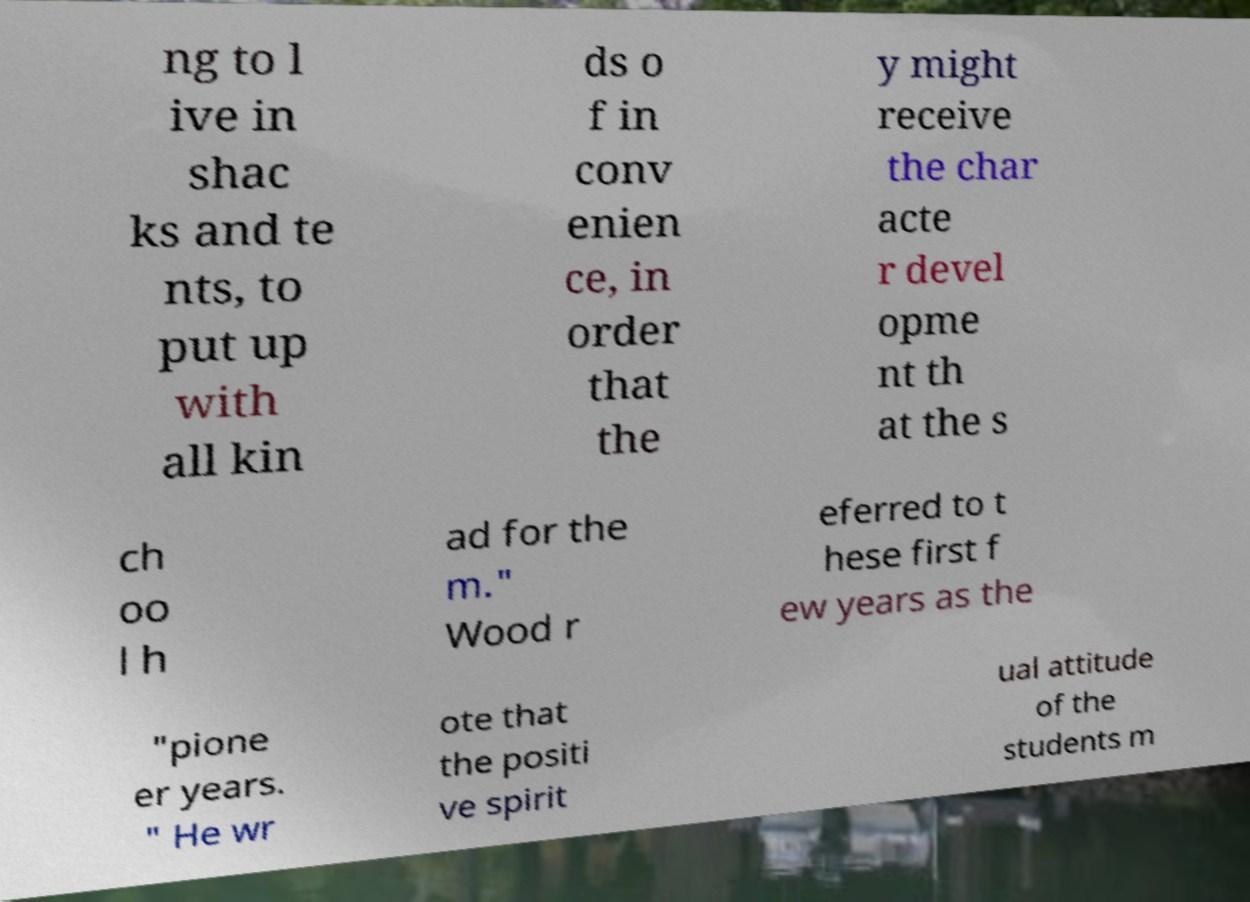Please read and relay the text visible in this image. What does it say? ng to l ive in shac ks and te nts, to put up with all kin ds o f in conv enien ce, in order that the y might receive the char acte r devel opme nt th at the s ch oo l h ad for the m." Wood r eferred to t hese first f ew years as the "pione er years. " He wr ote that the positi ve spirit ual attitude of the students m 